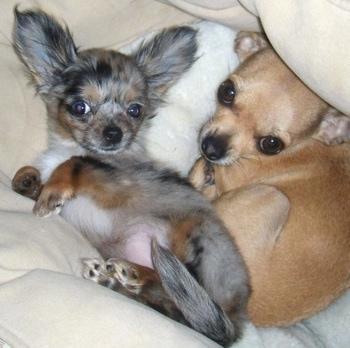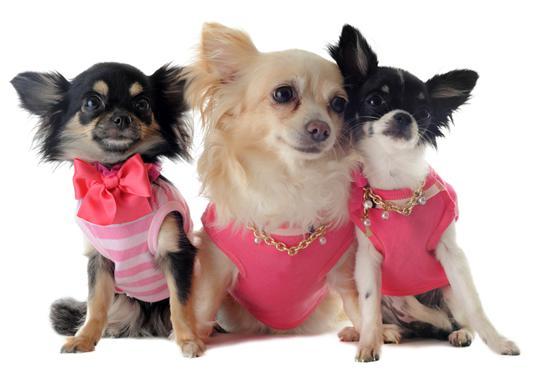The first image is the image on the left, the second image is the image on the right. Evaluate the accuracy of this statement regarding the images: "There are at least five chihuahuas.". Is it true? Answer yes or no. Yes. The first image is the image on the left, the second image is the image on the right. Evaluate the accuracy of this statement regarding the images: "The images show five dogs.". Is it true? Answer yes or no. Yes. 